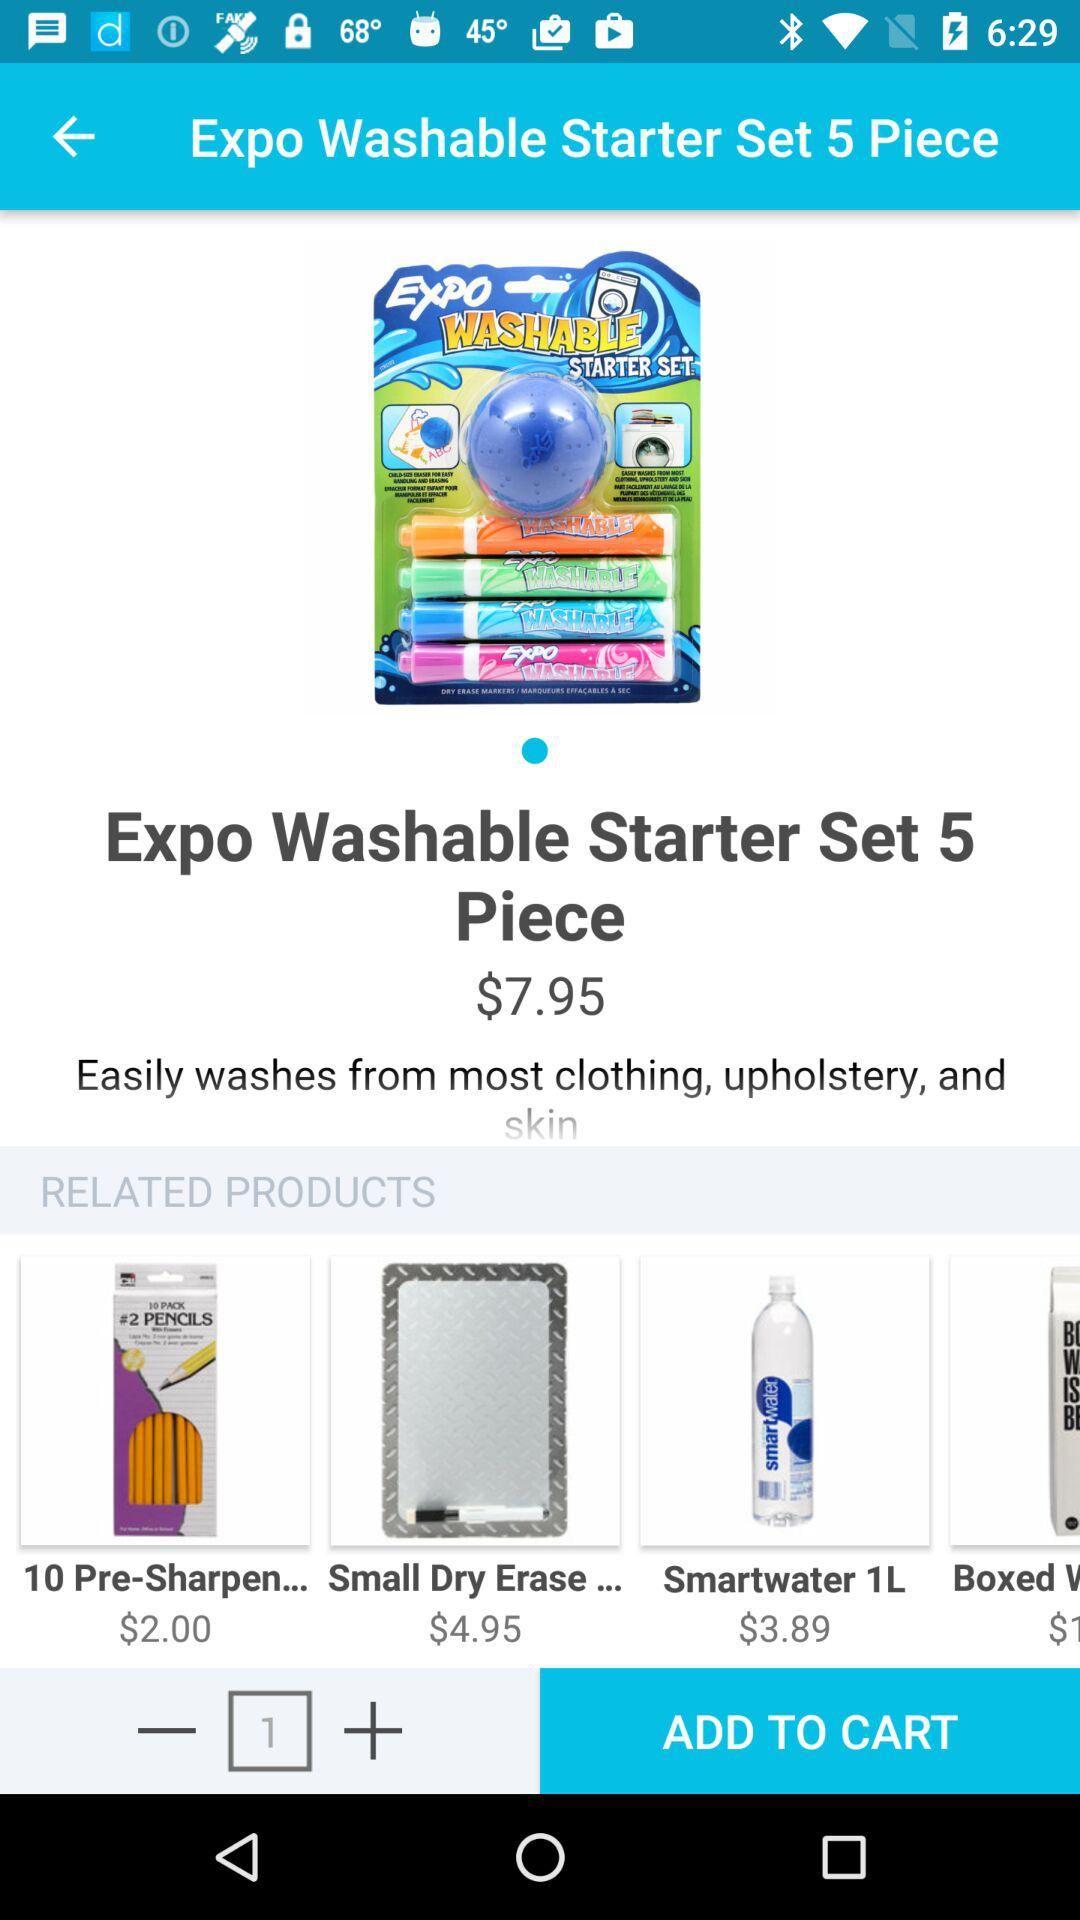How many items are in the cart?
When the provided information is insufficient, respond with <no answer>. <no answer> 